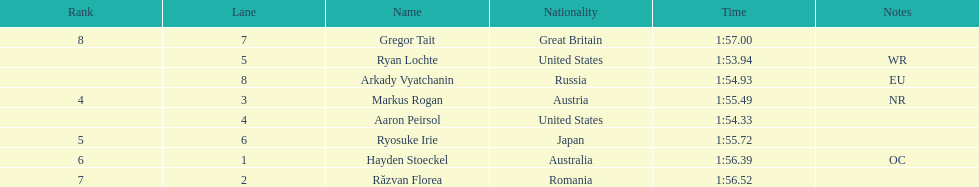How many names are listed? 8. 